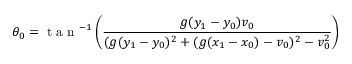Convert formula to latex. <formula><loc_0><loc_0><loc_500><loc_500>\theta _ { 0 } = t a n ^ { - 1 } \left ( \frac { g ( y _ { 1 } - y _ { 0 } ) v _ { 0 } } { ( g ( y _ { 1 } - y _ { 0 } ) ^ { 2 } + ( g ( x _ { 1 } - x _ { 0 } ) - v _ { 0 } ) ^ { 2 } - v _ { 0 } ^ { 2 } } \right )</formula> 